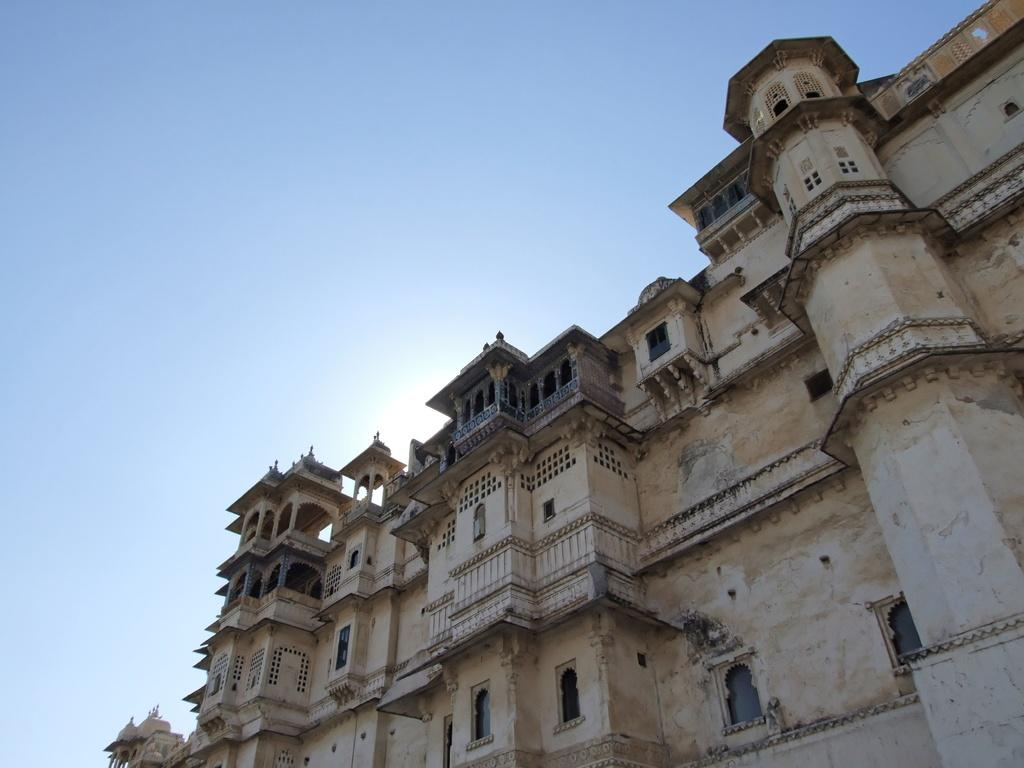What can be seen in the background of the image? The sky is visible in the image. What type of structure is present in the image? There is a building in the image. What feature of the building can be observed? The building has windows. How does the net help in the distribution of the building in the image? There is no net present in the image, and therefore it cannot be involved in the distribution of the building. 